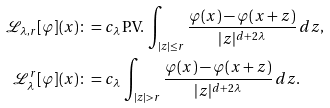<formula> <loc_0><loc_0><loc_500><loc_500>\mathcal { L } _ { \lambda , r } [ \varphi ] ( x ) & \colon = c _ { \lambda } \, \text {P.V.} \, \int _ { | z | \leq r } \frac { \varphi ( x ) - \varphi ( x + z ) } { | z | ^ { d + 2 \lambda } } \, d z , \\ \mathcal { L } _ { \lambda } ^ { r } [ \varphi ] ( x ) & \colon = c _ { \lambda } \, \int _ { | z | > r } \frac { \varphi ( x ) - \varphi ( x + z ) } { | z | ^ { d + 2 \lambda } } \, d z .</formula> 